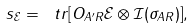Convert formula to latex. <formula><loc_0><loc_0><loc_500><loc_500>s _ { \mathcal { E } } = \ t r { \left [ O _ { A ^ { \prime } R } \mathcal { E } \otimes \mathcal { I } ( \sigma _ { A R } ) \right ] } ,</formula> 